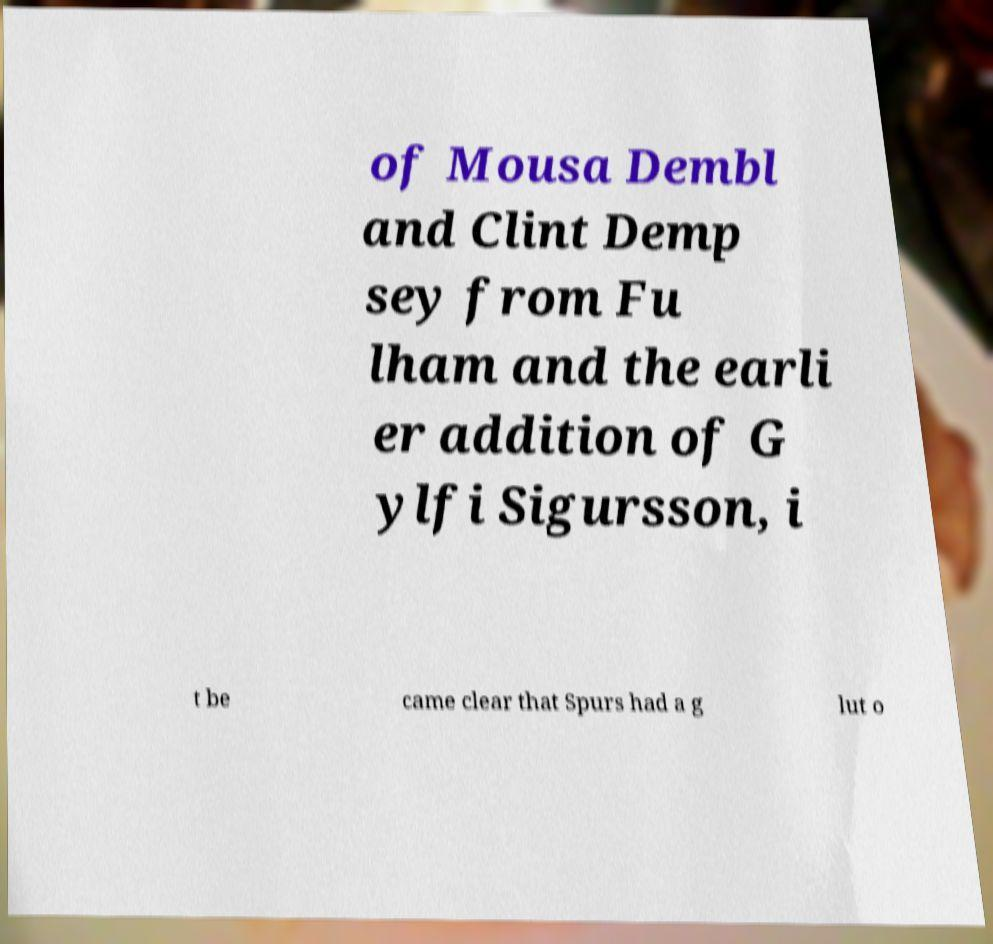What messages or text are displayed in this image? I need them in a readable, typed format. of Mousa Dembl and Clint Demp sey from Fu lham and the earli er addition of G ylfi Sigursson, i t be came clear that Spurs had a g lut o 